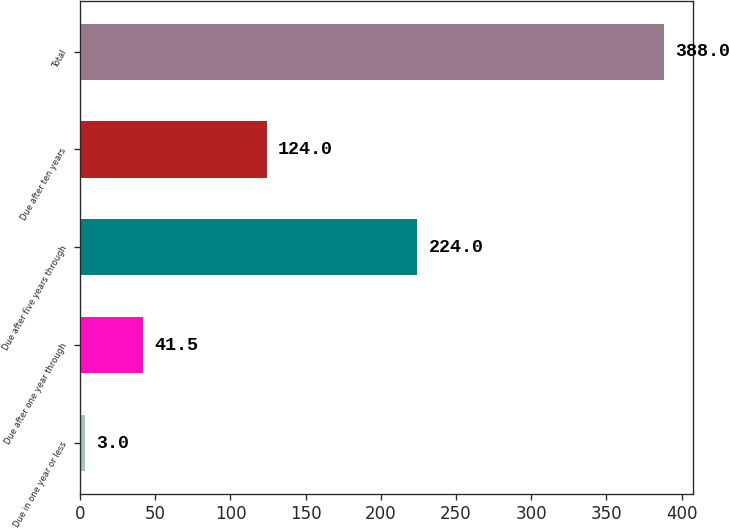Convert chart to OTSL. <chart><loc_0><loc_0><loc_500><loc_500><bar_chart><fcel>Due in one year or less<fcel>Due after one year through<fcel>Due after five years through<fcel>Due after ten years<fcel>Total<nl><fcel>3<fcel>41.5<fcel>224<fcel>124<fcel>388<nl></chart> 